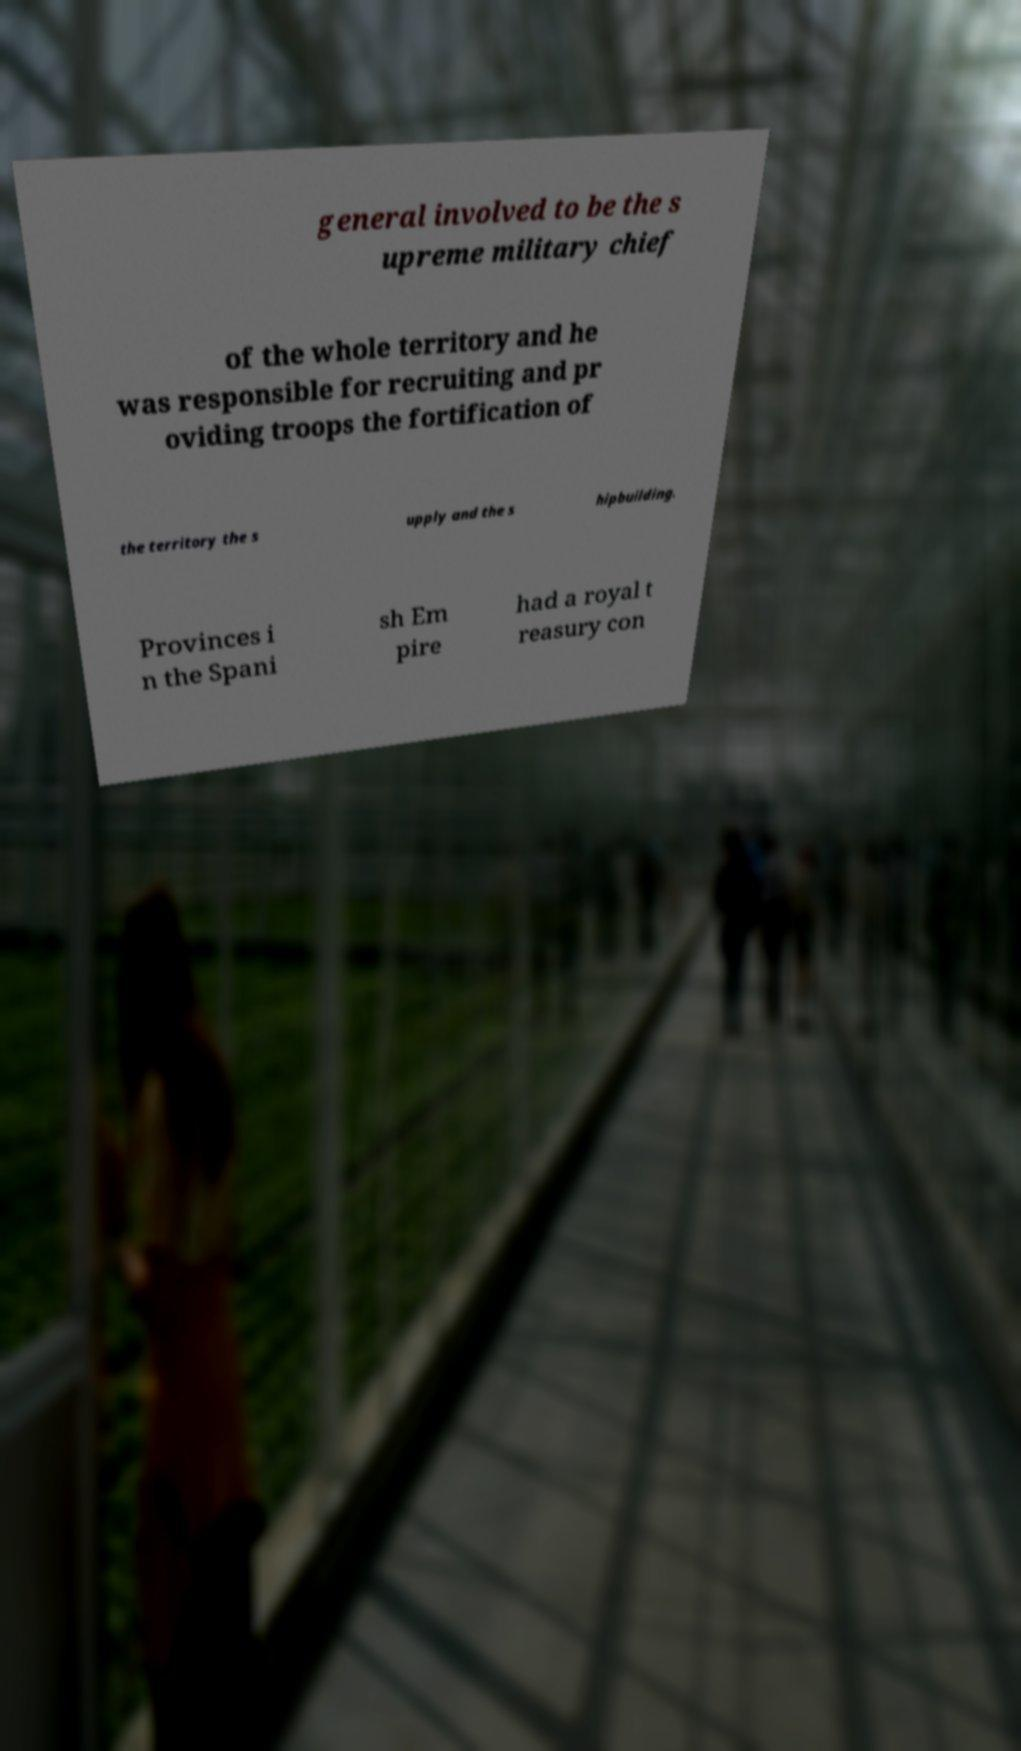Could you assist in decoding the text presented in this image and type it out clearly? general involved to be the s upreme military chief of the whole territory and he was responsible for recruiting and pr oviding troops the fortification of the territory the s upply and the s hipbuilding. Provinces i n the Spani sh Em pire had a royal t reasury con 